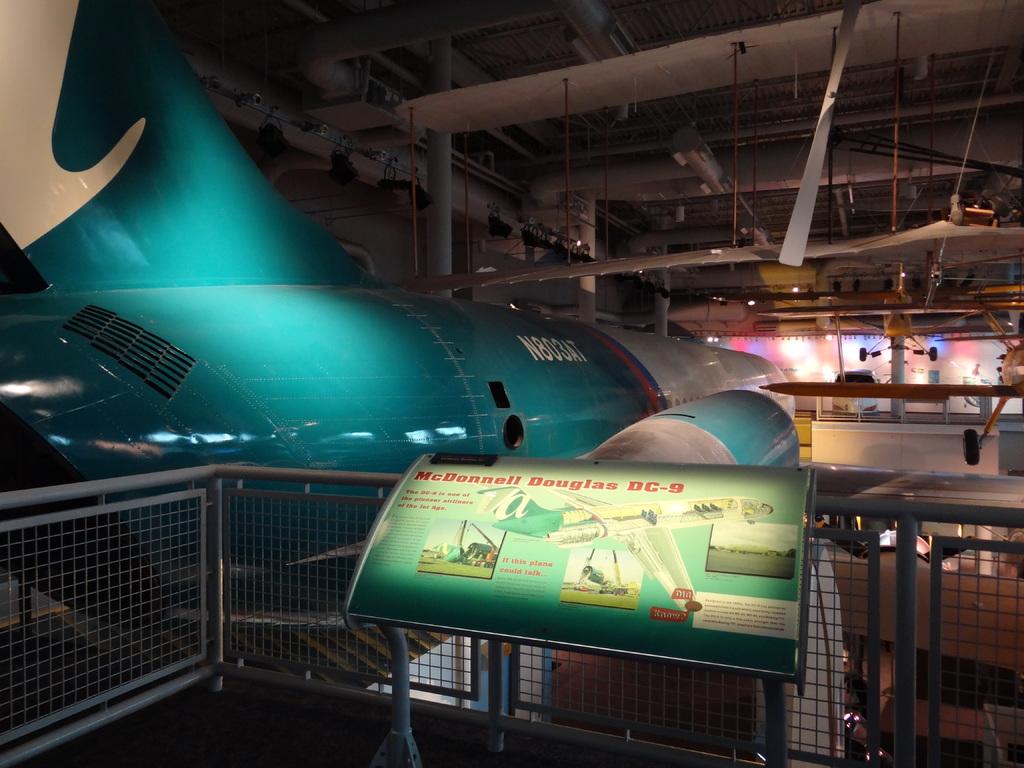What kind of plane is this?
Make the answer very short. Mcdonnell douglas dc-9. What is the plane identification number on the side of the plane?
Make the answer very short. N803at. 